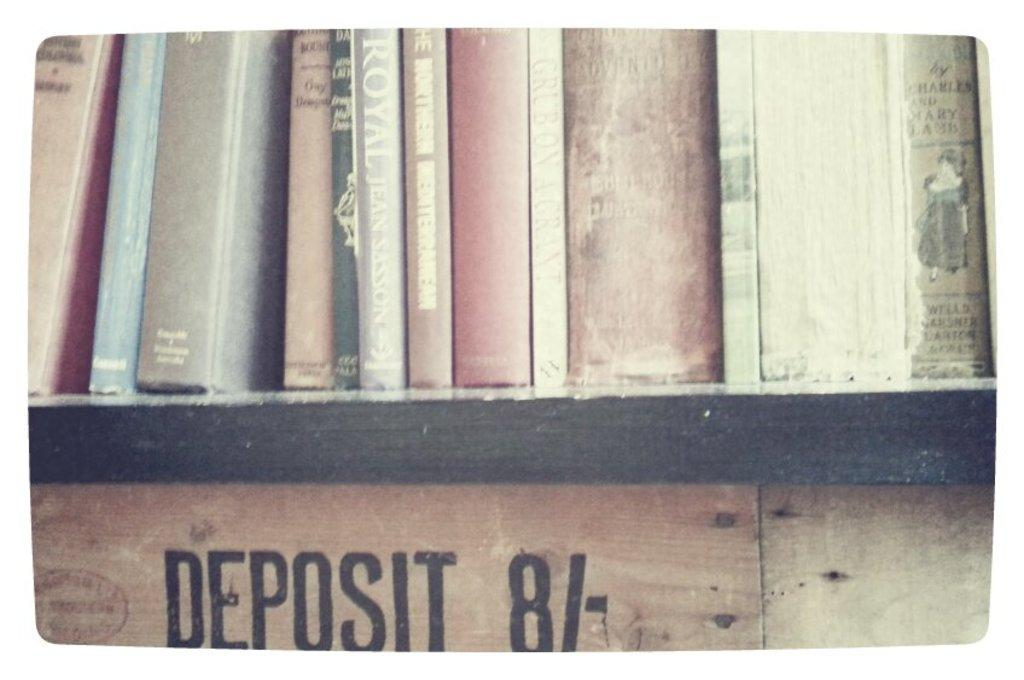What objects can be seen on a rack in the image? There are books on a rack in the image. What type of surface has text on it in the image? There is text on a wooden wall in the image. How many eyes can be seen on the chicken in the image? There is no chicken present in the image. What statement is being made by the text on the wooden wall in the image? The provided facts do not include the content of the text on the wooden wall, so we cannot determine the statement being made. 